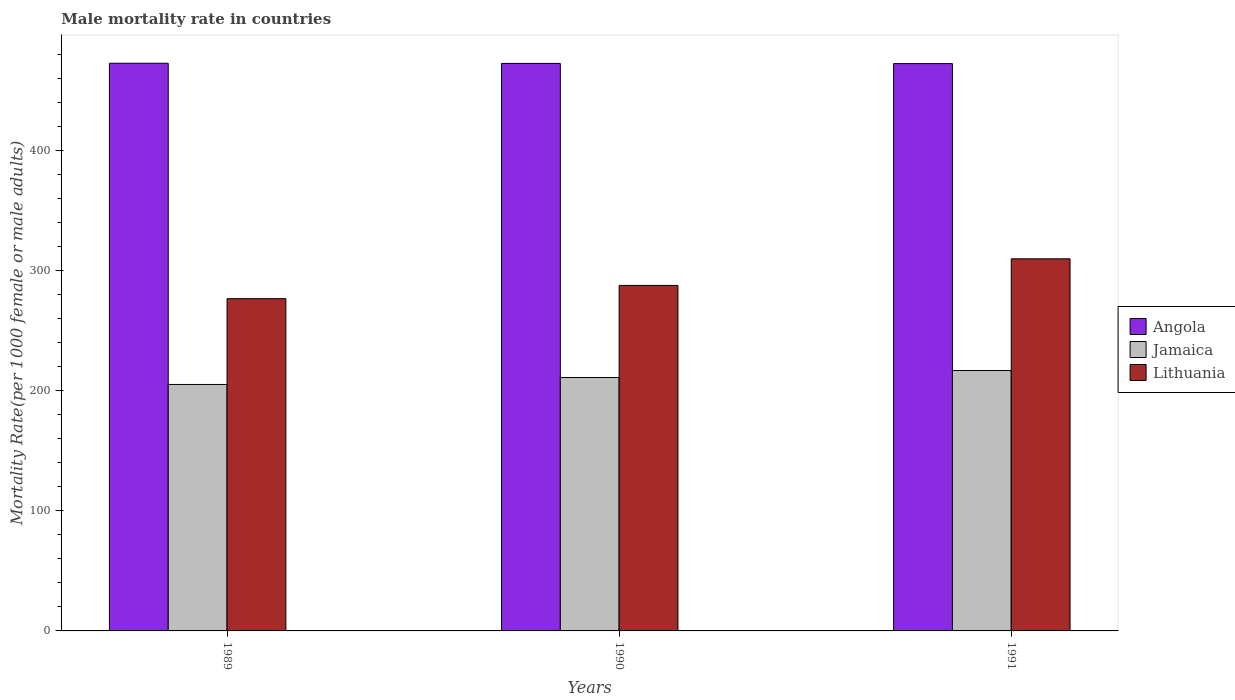How many different coloured bars are there?
Provide a succinct answer. 3. Are the number of bars per tick equal to the number of legend labels?
Give a very brief answer. Yes. How many bars are there on the 3rd tick from the left?
Ensure brevity in your answer.  3. How many bars are there on the 1st tick from the right?
Your response must be concise. 3. What is the male mortality rate in Angola in 1990?
Keep it short and to the point. 472.51. Across all years, what is the maximum male mortality rate in Lithuania?
Keep it short and to the point. 309.83. Across all years, what is the minimum male mortality rate in Lithuania?
Make the answer very short. 276.64. In which year was the male mortality rate in Lithuania maximum?
Your response must be concise. 1991. What is the total male mortality rate in Lithuania in the graph?
Keep it short and to the point. 874.15. What is the difference between the male mortality rate in Jamaica in 1990 and that in 1991?
Give a very brief answer. -5.8. What is the difference between the male mortality rate in Angola in 1989 and the male mortality rate in Lithuania in 1990?
Make the answer very short. 184.97. What is the average male mortality rate in Angola per year?
Your response must be concise. 472.51. In the year 1991, what is the difference between the male mortality rate in Jamaica and male mortality rate in Angola?
Provide a succinct answer. -255.55. In how many years, is the male mortality rate in Angola greater than 40?
Keep it short and to the point. 3. What is the ratio of the male mortality rate in Lithuania in 1989 to that in 1990?
Make the answer very short. 0.96. Is the difference between the male mortality rate in Jamaica in 1990 and 1991 greater than the difference between the male mortality rate in Angola in 1990 and 1991?
Your response must be concise. No. What is the difference between the highest and the second highest male mortality rate in Angola?
Provide a short and direct response. 0.14. What is the difference between the highest and the lowest male mortality rate in Angola?
Offer a terse response. 0.28. In how many years, is the male mortality rate in Angola greater than the average male mortality rate in Angola taken over all years?
Give a very brief answer. 1. What does the 2nd bar from the left in 1991 represents?
Offer a terse response. Jamaica. What does the 3rd bar from the right in 1989 represents?
Ensure brevity in your answer.  Angola. Is it the case that in every year, the sum of the male mortality rate in Lithuania and male mortality rate in Jamaica is greater than the male mortality rate in Angola?
Your response must be concise. Yes. Are all the bars in the graph horizontal?
Your answer should be very brief. No. Does the graph contain grids?
Ensure brevity in your answer.  No. Where does the legend appear in the graph?
Your answer should be compact. Center right. How many legend labels are there?
Your answer should be compact. 3. What is the title of the graph?
Offer a terse response. Male mortality rate in countries. Does "Monaco" appear as one of the legend labels in the graph?
Your answer should be compact. No. What is the label or title of the X-axis?
Keep it short and to the point. Years. What is the label or title of the Y-axis?
Keep it short and to the point. Mortality Rate(per 1000 female or male adults). What is the Mortality Rate(per 1000 female or male adults) of Angola in 1989?
Make the answer very short. 472.65. What is the Mortality Rate(per 1000 female or male adults) of Jamaica in 1989?
Make the answer very short. 205.21. What is the Mortality Rate(per 1000 female or male adults) of Lithuania in 1989?
Offer a terse response. 276.64. What is the Mortality Rate(per 1000 female or male adults) of Angola in 1990?
Your response must be concise. 472.51. What is the Mortality Rate(per 1000 female or male adults) in Jamaica in 1990?
Provide a succinct answer. 211.02. What is the Mortality Rate(per 1000 female or male adults) in Lithuania in 1990?
Keep it short and to the point. 287.68. What is the Mortality Rate(per 1000 female or male adults) in Angola in 1991?
Make the answer very short. 472.37. What is the Mortality Rate(per 1000 female or male adults) in Jamaica in 1991?
Keep it short and to the point. 216.82. What is the Mortality Rate(per 1000 female or male adults) in Lithuania in 1991?
Make the answer very short. 309.83. Across all years, what is the maximum Mortality Rate(per 1000 female or male adults) of Angola?
Offer a very short reply. 472.65. Across all years, what is the maximum Mortality Rate(per 1000 female or male adults) of Jamaica?
Provide a succinct answer. 216.82. Across all years, what is the maximum Mortality Rate(per 1000 female or male adults) of Lithuania?
Your answer should be very brief. 309.83. Across all years, what is the minimum Mortality Rate(per 1000 female or male adults) in Angola?
Ensure brevity in your answer.  472.37. Across all years, what is the minimum Mortality Rate(per 1000 female or male adults) of Jamaica?
Keep it short and to the point. 205.21. Across all years, what is the minimum Mortality Rate(per 1000 female or male adults) of Lithuania?
Ensure brevity in your answer.  276.64. What is the total Mortality Rate(per 1000 female or male adults) of Angola in the graph?
Provide a succinct answer. 1417.53. What is the total Mortality Rate(per 1000 female or male adults) in Jamaica in the graph?
Your answer should be very brief. 633.05. What is the total Mortality Rate(per 1000 female or male adults) in Lithuania in the graph?
Your answer should be very brief. 874.15. What is the difference between the Mortality Rate(per 1000 female or male adults) in Angola in 1989 and that in 1990?
Keep it short and to the point. 0.14. What is the difference between the Mortality Rate(per 1000 female or male adults) in Jamaica in 1989 and that in 1990?
Give a very brief answer. -5.8. What is the difference between the Mortality Rate(per 1000 female or male adults) in Lithuania in 1989 and that in 1990?
Offer a very short reply. -11.04. What is the difference between the Mortality Rate(per 1000 female or male adults) in Angola in 1989 and that in 1991?
Your answer should be very brief. 0.28. What is the difference between the Mortality Rate(per 1000 female or male adults) of Jamaica in 1989 and that in 1991?
Offer a terse response. -11.61. What is the difference between the Mortality Rate(per 1000 female or male adults) of Lithuania in 1989 and that in 1991?
Your answer should be compact. -33.19. What is the difference between the Mortality Rate(per 1000 female or male adults) of Angola in 1990 and that in 1991?
Give a very brief answer. 0.14. What is the difference between the Mortality Rate(per 1000 female or male adults) in Jamaica in 1990 and that in 1991?
Keep it short and to the point. -5.8. What is the difference between the Mortality Rate(per 1000 female or male adults) of Lithuania in 1990 and that in 1991?
Keep it short and to the point. -22.14. What is the difference between the Mortality Rate(per 1000 female or male adults) in Angola in 1989 and the Mortality Rate(per 1000 female or male adults) in Jamaica in 1990?
Keep it short and to the point. 261.64. What is the difference between the Mortality Rate(per 1000 female or male adults) of Angola in 1989 and the Mortality Rate(per 1000 female or male adults) of Lithuania in 1990?
Ensure brevity in your answer.  184.97. What is the difference between the Mortality Rate(per 1000 female or male adults) of Jamaica in 1989 and the Mortality Rate(per 1000 female or male adults) of Lithuania in 1990?
Provide a succinct answer. -82.47. What is the difference between the Mortality Rate(per 1000 female or male adults) in Angola in 1989 and the Mortality Rate(per 1000 female or male adults) in Jamaica in 1991?
Ensure brevity in your answer.  255.83. What is the difference between the Mortality Rate(per 1000 female or male adults) of Angola in 1989 and the Mortality Rate(per 1000 female or male adults) of Lithuania in 1991?
Ensure brevity in your answer.  162.83. What is the difference between the Mortality Rate(per 1000 female or male adults) of Jamaica in 1989 and the Mortality Rate(per 1000 female or male adults) of Lithuania in 1991?
Your answer should be very brief. -104.61. What is the difference between the Mortality Rate(per 1000 female or male adults) of Angola in 1990 and the Mortality Rate(per 1000 female or male adults) of Jamaica in 1991?
Provide a succinct answer. 255.69. What is the difference between the Mortality Rate(per 1000 female or male adults) of Angola in 1990 and the Mortality Rate(per 1000 female or male adults) of Lithuania in 1991?
Keep it short and to the point. 162.68. What is the difference between the Mortality Rate(per 1000 female or male adults) of Jamaica in 1990 and the Mortality Rate(per 1000 female or male adults) of Lithuania in 1991?
Your answer should be very brief. -98.81. What is the average Mortality Rate(per 1000 female or male adults) in Angola per year?
Your response must be concise. 472.51. What is the average Mortality Rate(per 1000 female or male adults) in Jamaica per year?
Make the answer very short. 211.02. What is the average Mortality Rate(per 1000 female or male adults) of Lithuania per year?
Keep it short and to the point. 291.38. In the year 1989, what is the difference between the Mortality Rate(per 1000 female or male adults) of Angola and Mortality Rate(per 1000 female or male adults) of Jamaica?
Your answer should be compact. 267.44. In the year 1989, what is the difference between the Mortality Rate(per 1000 female or male adults) in Angola and Mortality Rate(per 1000 female or male adults) in Lithuania?
Provide a succinct answer. 196.02. In the year 1989, what is the difference between the Mortality Rate(per 1000 female or male adults) in Jamaica and Mortality Rate(per 1000 female or male adults) in Lithuania?
Offer a terse response. -71.42. In the year 1990, what is the difference between the Mortality Rate(per 1000 female or male adults) in Angola and Mortality Rate(per 1000 female or male adults) in Jamaica?
Your answer should be very brief. 261.49. In the year 1990, what is the difference between the Mortality Rate(per 1000 female or male adults) in Angola and Mortality Rate(per 1000 female or male adults) in Lithuania?
Provide a succinct answer. 184.83. In the year 1990, what is the difference between the Mortality Rate(per 1000 female or male adults) of Jamaica and Mortality Rate(per 1000 female or male adults) of Lithuania?
Your answer should be very brief. -76.66. In the year 1991, what is the difference between the Mortality Rate(per 1000 female or male adults) of Angola and Mortality Rate(per 1000 female or male adults) of Jamaica?
Give a very brief answer. 255.55. In the year 1991, what is the difference between the Mortality Rate(per 1000 female or male adults) of Angola and Mortality Rate(per 1000 female or male adults) of Lithuania?
Provide a succinct answer. 162.54. In the year 1991, what is the difference between the Mortality Rate(per 1000 female or male adults) of Jamaica and Mortality Rate(per 1000 female or male adults) of Lithuania?
Offer a terse response. -93.01. What is the ratio of the Mortality Rate(per 1000 female or male adults) of Jamaica in 1989 to that in 1990?
Your response must be concise. 0.97. What is the ratio of the Mortality Rate(per 1000 female or male adults) of Lithuania in 1989 to that in 1990?
Your answer should be compact. 0.96. What is the ratio of the Mortality Rate(per 1000 female or male adults) of Jamaica in 1989 to that in 1991?
Your response must be concise. 0.95. What is the ratio of the Mortality Rate(per 1000 female or male adults) of Lithuania in 1989 to that in 1991?
Make the answer very short. 0.89. What is the ratio of the Mortality Rate(per 1000 female or male adults) of Jamaica in 1990 to that in 1991?
Offer a very short reply. 0.97. What is the ratio of the Mortality Rate(per 1000 female or male adults) in Lithuania in 1990 to that in 1991?
Provide a succinct answer. 0.93. What is the difference between the highest and the second highest Mortality Rate(per 1000 female or male adults) of Angola?
Offer a very short reply. 0.14. What is the difference between the highest and the second highest Mortality Rate(per 1000 female or male adults) in Jamaica?
Give a very brief answer. 5.8. What is the difference between the highest and the second highest Mortality Rate(per 1000 female or male adults) in Lithuania?
Offer a very short reply. 22.14. What is the difference between the highest and the lowest Mortality Rate(per 1000 female or male adults) in Angola?
Your response must be concise. 0.28. What is the difference between the highest and the lowest Mortality Rate(per 1000 female or male adults) in Jamaica?
Your response must be concise. 11.61. What is the difference between the highest and the lowest Mortality Rate(per 1000 female or male adults) in Lithuania?
Keep it short and to the point. 33.19. 